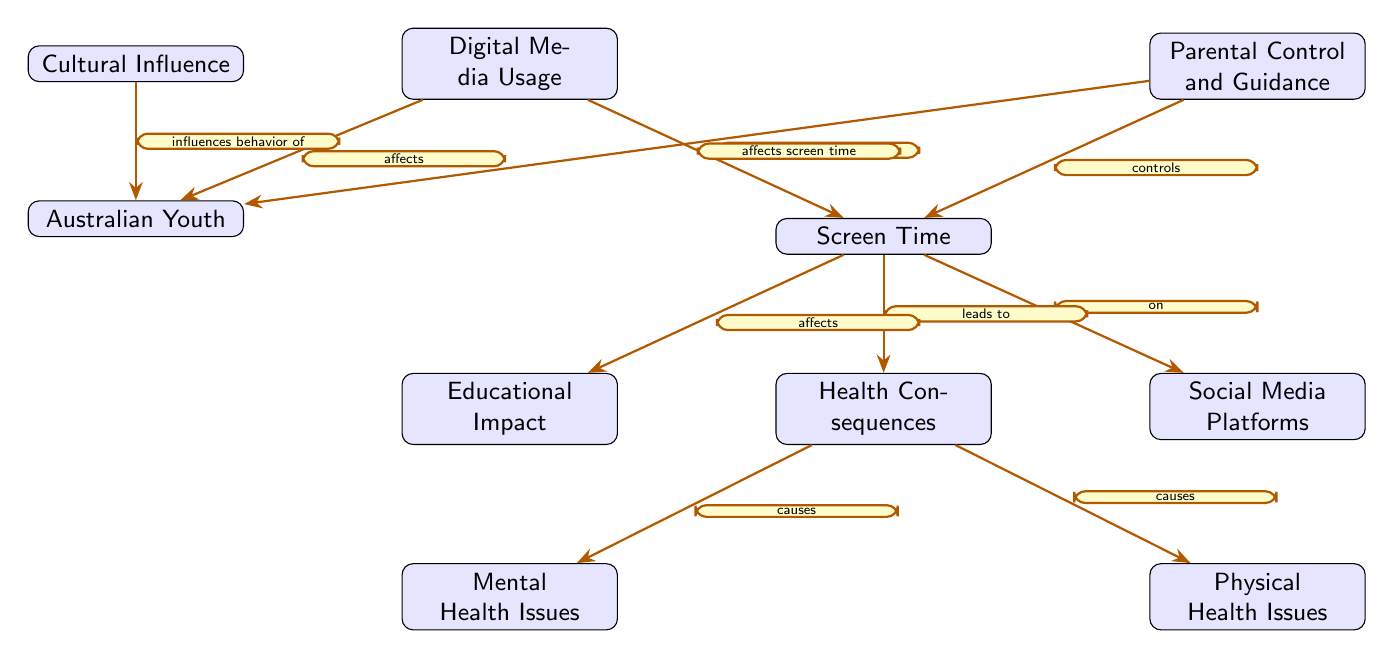What is the central theme of the diagram? The central theme of the diagram revolves around "Digital Media Usage," indicated by the topmost node. This node is the starting point for the relationships depicted within the diagram, highlighting the various impacts and considerations regarding screen time among Australian youth.
Answer: Digital Media Usage How many nodes are present in the diagram? The diagram contains a total of 10 nodes, which are distinct entities represented visually to convey information regarding digital media and its effects on youth. Each node corresponds to a specific aspect related to the overall theme of the diagram.
Answer: 10 What relationship does "Screen Time" have with "Social Media Platforms"? "Screen Time" has a direct relationship with "Social Media Platforms," as indicated by the edge connecting these two nodes, with the label "on." This suggests that screen time is a factor that relates specifically to social media usage.
Answer: on Which node results from "Screen Time" leading to "Health Consequences"? "Health Consequences" is directly affected by "Screen Time," as indicated by the label "leads to," showing that increased screen time has a causal effect on health-related issues.
Answer: Health Consequences What influences the behavior of Australian Youth in the diagram? The diagram indicates that "Cultural Influence" specifically influences the behavior of "Australian Youth," as depicted by the connecting edge that directly points from one to the other, illustrating a clear causal relationship.
Answer: Cultural Influence How do "Parental Control and Guidance" affect "Screen Time"? The diagram demonstrates that "Parental Control and Guidance" directly "affects" "Screen Time," implying that parental involvement can impact the amount of time youths spend on screens. This is reflected in the directional edge illustrated in the diagram.
Answer: affects What causes "Mental Health Issues" in the diagram? "Mental Health Issues" are shown to be caused by "Health Consequences," which is in turn influenced by "Screen Time." This relationship is established through the causal connections outlined in the diagram, illustrating the chain of effects.
Answer: causes What is the connection between "Digital Media Usage" and "Australian Youth"? The connection is that "Digital Media Usage" specifically "affects" "Australian Youth," indicating that how digital media is consumed plays a significant role in shaping experiences and behaviors among young Australians.
Answer: affects What type of influence does "Cultural Influence" exert on "Australian Youth"? "Cultural Influence" exerts an "influence behavior of" type of impact on "Australian Youth," highlighting the role of cultural factors in shaping youth behavior beyond digital media itself.
Answer: influences behavior of 